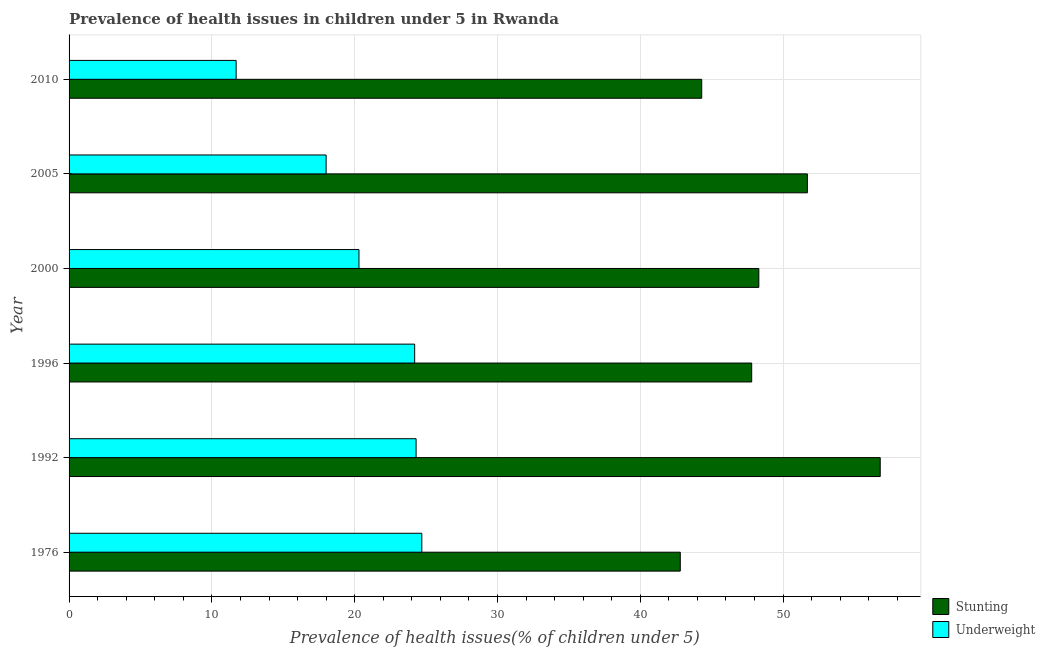Are the number of bars on each tick of the Y-axis equal?
Your response must be concise. Yes. How many bars are there on the 6th tick from the bottom?
Provide a short and direct response. 2. In how many cases, is the number of bars for a given year not equal to the number of legend labels?
Your answer should be very brief. 0. What is the percentage of stunted children in 2005?
Your response must be concise. 51.7. Across all years, what is the maximum percentage of underweight children?
Make the answer very short. 24.7. Across all years, what is the minimum percentage of underweight children?
Keep it short and to the point. 11.7. In which year was the percentage of underweight children maximum?
Your answer should be very brief. 1976. What is the total percentage of underweight children in the graph?
Your response must be concise. 123.2. What is the difference between the percentage of underweight children in 2000 and the percentage of stunted children in 2005?
Keep it short and to the point. -31.4. What is the average percentage of underweight children per year?
Ensure brevity in your answer.  20.53. In the year 2000, what is the difference between the percentage of underweight children and percentage of stunted children?
Offer a terse response. -28. What is the ratio of the percentage of underweight children in 1992 to that in 2000?
Make the answer very short. 1.2. What is the difference between the highest and the second highest percentage of stunted children?
Provide a short and direct response. 5.1. What is the difference between the highest and the lowest percentage of underweight children?
Make the answer very short. 13. In how many years, is the percentage of stunted children greater than the average percentage of stunted children taken over all years?
Provide a succinct answer. 2. What does the 1st bar from the top in 2005 represents?
Offer a very short reply. Underweight. What does the 1st bar from the bottom in 1976 represents?
Provide a short and direct response. Stunting. How many bars are there?
Provide a succinct answer. 12. Are the values on the major ticks of X-axis written in scientific E-notation?
Your answer should be compact. No. Does the graph contain any zero values?
Make the answer very short. No. Where does the legend appear in the graph?
Your answer should be very brief. Bottom right. What is the title of the graph?
Your answer should be compact. Prevalence of health issues in children under 5 in Rwanda. What is the label or title of the X-axis?
Ensure brevity in your answer.  Prevalence of health issues(% of children under 5). What is the label or title of the Y-axis?
Offer a very short reply. Year. What is the Prevalence of health issues(% of children under 5) in Stunting in 1976?
Give a very brief answer. 42.8. What is the Prevalence of health issues(% of children under 5) of Underweight in 1976?
Your answer should be very brief. 24.7. What is the Prevalence of health issues(% of children under 5) of Stunting in 1992?
Make the answer very short. 56.8. What is the Prevalence of health issues(% of children under 5) of Underweight in 1992?
Make the answer very short. 24.3. What is the Prevalence of health issues(% of children under 5) in Stunting in 1996?
Provide a short and direct response. 47.8. What is the Prevalence of health issues(% of children under 5) in Underweight in 1996?
Your answer should be very brief. 24.2. What is the Prevalence of health issues(% of children under 5) of Stunting in 2000?
Offer a very short reply. 48.3. What is the Prevalence of health issues(% of children under 5) of Underweight in 2000?
Your answer should be very brief. 20.3. What is the Prevalence of health issues(% of children under 5) in Stunting in 2005?
Offer a very short reply. 51.7. What is the Prevalence of health issues(% of children under 5) of Stunting in 2010?
Give a very brief answer. 44.3. What is the Prevalence of health issues(% of children under 5) in Underweight in 2010?
Ensure brevity in your answer.  11.7. Across all years, what is the maximum Prevalence of health issues(% of children under 5) in Stunting?
Make the answer very short. 56.8. Across all years, what is the maximum Prevalence of health issues(% of children under 5) in Underweight?
Provide a short and direct response. 24.7. Across all years, what is the minimum Prevalence of health issues(% of children under 5) of Stunting?
Your response must be concise. 42.8. Across all years, what is the minimum Prevalence of health issues(% of children under 5) of Underweight?
Provide a short and direct response. 11.7. What is the total Prevalence of health issues(% of children under 5) of Stunting in the graph?
Keep it short and to the point. 291.7. What is the total Prevalence of health issues(% of children under 5) of Underweight in the graph?
Make the answer very short. 123.2. What is the difference between the Prevalence of health issues(% of children under 5) in Underweight in 1976 and that in 1996?
Provide a short and direct response. 0.5. What is the difference between the Prevalence of health issues(% of children under 5) in Stunting in 1976 and that in 2000?
Your response must be concise. -5.5. What is the difference between the Prevalence of health issues(% of children under 5) of Underweight in 1976 and that in 2000?
Your response must be concise. 4.4. What is the difference between the Prevalence of health issues(% of children under 5) in Underweight in 1992 and that in 1996?
Your response must be concise. 0.1. What is the difference between the Prevalence of health issues(% of children under 5) in Stunting in 1992 and that in 2000?
Give a very brief answer. 8.5. What is the difference between the Prevalence of health issues(% of children under 5) in Underweight in 1992 and that in 2000?
Provide a short and direct response. 4. What is the difference between the Prevalence of health issues(% of children under 5) in Stunting in 1992 and that in 2005?
Make the answer very short. 5.1. What is the difference between the Prevalence of health issues(% of children under 5) in Stunting in 1992 and that in 2010?
Your answer should be compact. 12.5. What is the difference between the Prevalence of health issues(% of children under 5) of Underweight in 1992 and that in 2010?
Keep it short and to the point. 12.6. What is the difference between the Prevalence of health issues(% of children under 5) of Stunting in 1996 and that in 2000?
Keep it short and to the point. -0.5. What is the difference between the Prevalence of health issues(% of children under 5) of Stunting in 1996 and that in 2005?
Provide a succinct answer. -3.9. What is the difference between the Prevalence of health issues(% of children under 5) of Underweight in 1996 and that in 2010?
Your answer should be very brief. 12.5. What is the difference between the Prevalence of health issues(% of children under 5) in Stunting in 2000 and that in 2005?
Offer a terse response. -3.4. What is the difference between the Prevalence of health issues(% of children under 5) in Underweight in 2000 and that in 2005?
Your answer should be very brief. 2.3. What is the difference between the Prevalence of health issues(% of children under 5) of Underweight in 2000 and that in 2010?
Ensure brevity in your answer.  8.6. What is the difference between the Prevalence of health issues(% of children under 5) in Stunting in 2005 and that in 2010?
Offer a terse response. 7.4. What is the difference between the Prevalence of health issues(% of children under 5) in Underweight in 2005 and that in 2010?
Give a very brief answer. 6.3. What is the difference between the Prevalence of health issues(% of children under 5) in Stunting in 1976 and the Prevalence of health issues(% of children under 5) in Underweight in 2000?
Your response must be concise. 22.5. What is the difference between the Prevalence of health issues(% of children under 5) of Stunting in 1976 and the Prevalence of health issues(% of children under 5) of Underweight in 2005?
Provide a short and direct response. 24.8. What is the difference between the Prevalence of health issues(% of children under 5) in Stunting in 1976 and the Prevalence of health issues(% of children under 5) in Underweight in 2010?
Provide a short and direct response. 31.1. What is the difference between the Prevalence of health issues(% of children under 5) of Stunting in 1992 and the Prevalence of health issues(% of children under 5) of Underweight in 1996?
Give a very brief answer. 32.6. What is the difference between the Prevalence of health issues(% of children under 5) of Stunting in 1992 and the Prevalence of health issues(% of children under 5) of Underweight in 2000?
Your answer should be compact. 36.5. What is the difference between the Prevalence of health issues(% of children under 5) of Stunting in 1992 and the Prevalence of health issues(% of children under 5) of Underweight in 2005?
Keep it short and to the point. 38.8. What is the difference between the Prevalence of health issues(% of children under 5) in Stunting in 1992 and the Prevalence of health issues(% of children under 5) in Underweight in 2010?
Offer a very short reply. 45.1. What is the difference between the Prevalence of health issues(% of children under 5) in Stunting in 1996 and the Prevalence of health issues(% of children under 5) in Underweight in 2000?
Offer a terse response. 27.5. What is the difference between the Prevalence of health issues(% of children under 5) in Stunting in 1996 and the Prevalence of health issues(% of children under 5) in Underweight in 2005?
Your answer should be very brief. 29.8. What is the difference between the Prevalence of health issues(% of children under 5) in Stunting in 1996 and the Prevalence of health issues(% of children under 5) in Underweight in 2010?
Give a very brief answer. 36.1. What is the difference between the Prevalence of health issues(% of children under 5) of Stunting in 2000 and the Prevalence of health issues(% of children under 5) of Underweight in 2005?
Keep it short and to the point. 30.3. What is the difference between the Prevalence of health issues(% of children under 5) in Stunting in 2000 and the Prevalence of health issues(% of children under 5) in Underweight in 2010?
Provide a succinct answer. 36.6. What is the average Prevalence of health issues(% of children under 5) in Stunting per year?
Provide a succinct answer. 48.62. What is the average Prevalence of health issues(% of children under 5) in Underweight per year?
Your response must be concise. 20.53. In the year 1976, what is the difference between the Prevalence of health issues(% of children under 5) in Stunting and Prevalence of health issues(% of children under 5) in Underweight?
Your answer should be compact. 18.1. In the year 1992, what is the difference between the Prevalence of health issues(% of children under 5) of Stunting and Prevalence of health issues(% of children under 5) of Underweight?
Offer a terse response. 32.5. In the year 1996, what is the difference between the Prevalence of health issues(% of children under 5) in Stunting and Prevalence of health issues(% of children under 5) in Underweight?
Offer a very short reply. 23.6. In the year 2000, what is the difference between the Prevalence of health issues(% of children under 5) of Stunting and Prevalence of health issues(% of children under 5) of Underweight?
Provide a succinct answer. 28. In the year 2005, what is the difference between the Prevalence of health issues(% of children under 5) of Stunting and Prevalence of health issues(% of children under 5) of Underweight?
Keep it short and to the point. 33.7. In the year 2010, what is the difference between the Prevalence of health issues(% of children under 5) of Stunting and Prevalence of health issues(% of children under 5) of Underweight?
Provide a short and direct response. 32.6. What is the ratio of the Prevalence of health issues(% of children under 5) of Stunting in 1976 to that in 1992?
Your answer should be very brief. 0.75. What is the ratio of the Prevalence of health issues(% of children under 5) in Underweight in 1976 to that in 1992?
Your answer should be compact. 1.02. What is the ratio of the Prevalence of health issues(% of children under 5) in Stunting in 1976 to that in 1996?
Your answer should be very brief. 0.9. What is the ratio of the Prevalence of health issues(% of children under 5) in Underweight in 1976 to that in 1996?
Provide a short and direct response. 1.02. What is the ratio of the Prevalence of health issues(% of children under 5) of Stunting in 1976 to that in 2000?
Ensure brevity in your answer.  0.89. What is the ratio of the Prevalence of health issues(% of children under 5) in Underweight in 1976 to that in 2000?
Offer a terse response. 1.22. What is the ratio of the Prevalence of health issues(% of children under 5) in Stunting in 1976 to that in 2005?
Offer a very short reply. 0.83. What is the ratio of the Prevalence of health issues(% of children under 5) of Underweight in 1976 to that in 2005?
Ensure brevity in your answer.  1.37. What is the ratio of the Prevalence of health issues(% of children under 5) of Stunting in 1976 to that in 2010?
Give a very brief answer. 0.97. What is the ratio of the Prevalence of health issues(% of children under 5) in Underweight in 1976 to that in 2010?
Your answer should be compact. 2.11. What is the ratio of the Prevalence of health issues(% of children under 5) of Stunting in 1992 to that in 1996?
Provide a succinct answer. 1.19. What is the ratio of the Prevalence of health issues(% of children under 5) of Stunting in 1992 to that in 2000?
Provide a short and direct response. 1.18. What is the ratio of the Prevalence of health issues(% of children under 5) of Underweight in 1992 to that in 2000?
Offer a very short reply. 1.2. What is the ratio of the Prevalence of health issues(% of children under 5) in Stunting in 1992 to that in 2005?
Ensure brevity in your answer.  1.1. What is the ratio of the Prevalence of health issues(% of children under 5) in Underweight in 1992 to that in 2005?
Your answer should be very brief. 1.35. What is the ratio of the Prevalence of health issues(% of children under 5) in Stunting in 1992 to that in 2010?
Offer a terse response. 1.28. What is the ratio of the Prevalence of health issues(% of children under 5) of Underweight in 1992 to that in 2010?
Provide a succinct answer. 2.08. What is the ratio of the Prevalence of health issues(% of children under 5) in Underweight in 1996 to that in 2000?
Your response must be concise. 1.19. What is the ratio of the Prevalence of health issues(% of children under 5) in Stunting in 1996 to that in 2005?
Your answer should be compact. 0.92. What is the ratio of the Prevalence of health issues(% of children under 5) of Underweight in 1996 to that in 2005?
Offer a very short reply. 1.34. What is the ratio of the Prevalence of health issues(% of children under 5) of Stunting in 1996 to that in 2010?
Make the answer very short. 1.08. What is the ratio of the Prevalence of health issues(% of children under 5) in Underweight in 1996 to that in 2010?
Keep it short and to the point. 2.07. What is the ratio of the Prevalence of health issues(% of children under 5) of Stunting in 2000 to that in 2005?
Your response must be concise. 0.93. What is the ratio of the Prevalence of health issues(% of children under 5) of Underweight in 2000 to that in 2005?
Offer a very short reply. 1.13. What is the ratio of the Prevalence of health issues(% of children under 5) in Stunting in 2000 to that in 2010?
Make the answer very short. 1.09. What is the ratio of the Prevalence of health issues(% of children under 5) in Underweight in 2000 to that in 2010?
Your answer should be very brief. 1.74. What is the ratio of the Prevalence of health issues(% of children under 5) in Stunting in 2005 to that in 2010?
Ensure brevity in your answer.  1.17. What is the ratio of the Prevalence of health issues(% of children under 5) of Underweight in 2005 to that in 2010?
Make the answer very short. 1.54. What is the difference between the highest and the second highest Prevalence of health issues(% of children under 5) in Underweight?
Your answer should be compact. 0.4. 